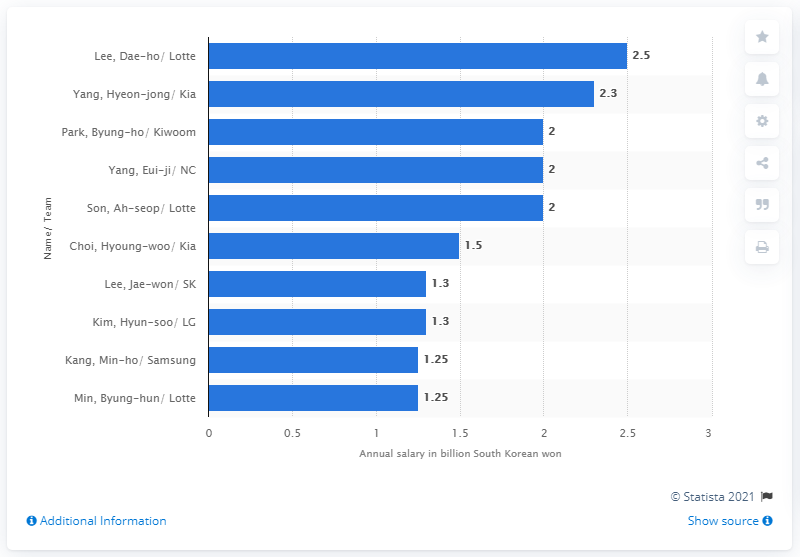Outline some significant characteristics in this image. Dae-ho Lee's annual salary was 2.5 million dollars. 